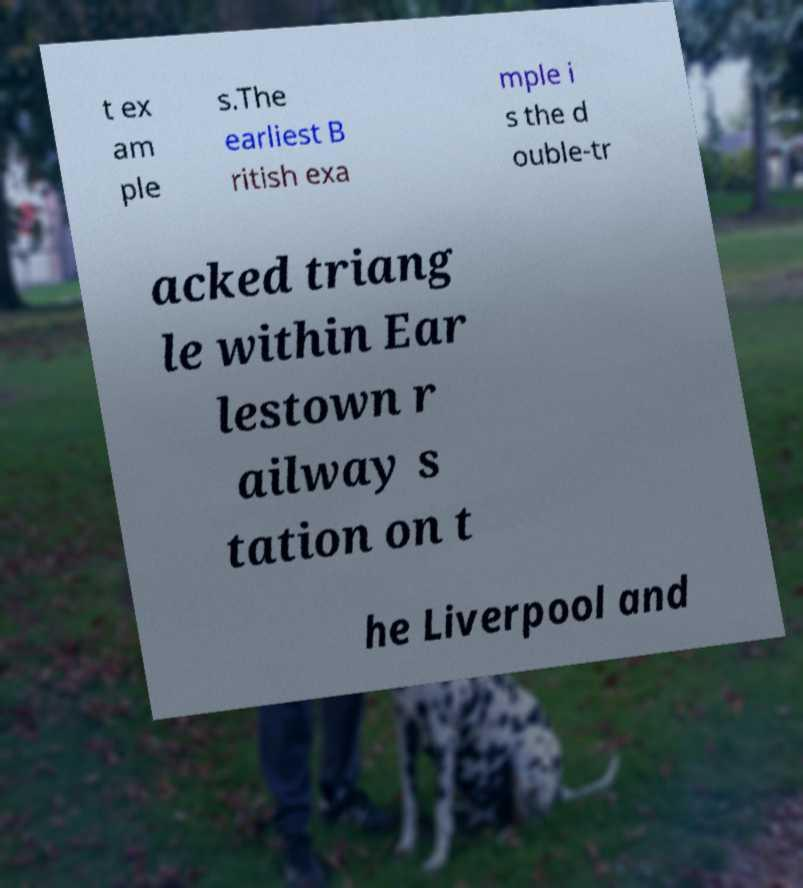Can you read and provide the text displayed in the image?This photo seems to have some interesting text. Can you extract and type it out for me? t ex am ple s.The earliest B ritish exa mple i s the d ouble-tr acked triang le within Ear lestown r ailway s tation on t he Liverpool and 